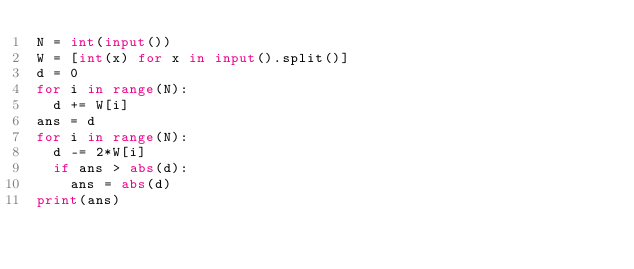<code> <loc_0><loc_0><loc_500><loc_500><_Python_>N = int(input())
W = [int(x) for x in input().split()]
d = 0
for i in range(N):
  d += W[i]
ans = d
for i in range(N):
  d -= 2*W[i]
  if ans > abs(d):
    ans = abs(d)
print(ans)</code> 